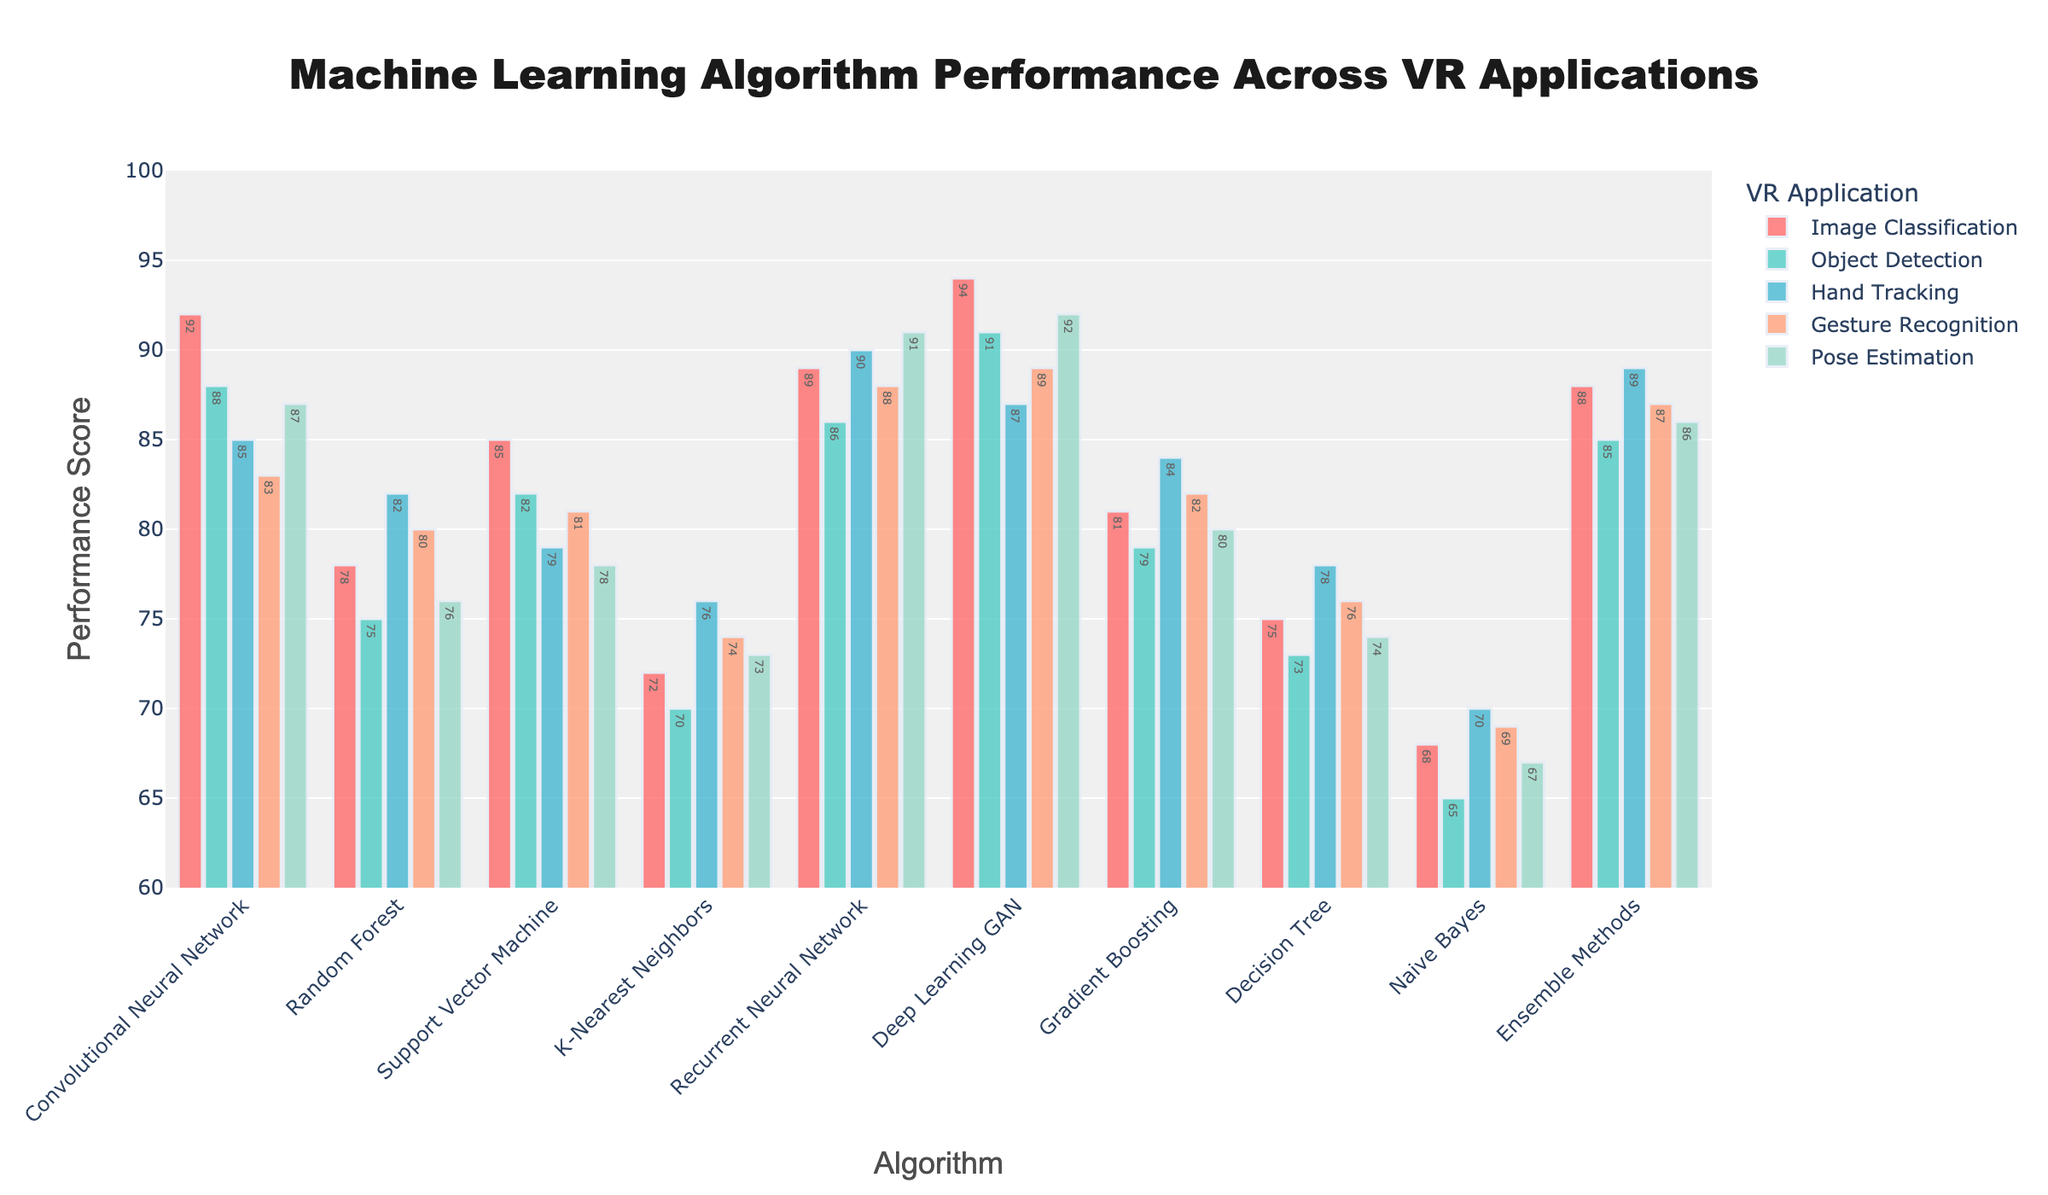What is the highest performance score achieved by any algorithm for Gesture Recognition? To find the highest performance score, look at the bar heights for Gesture Recognition across all algorithms. The highest bar is "Deep Learning GAN" with a score of 89.
Answer: 89 Which algorithm performs better in Hand Tracking, Convolutional Neural Network or Support Vector Machine? Compare the bar heights of Convolutional Neural Network (85) and Support Vector Machine (79) in Hand Tracking. The Convolutional Neural Network has the higher score.
Answer: Convolutional Neural Network How many algorithms scored above 80 in Image Classification? Count all algorithms with bars above the 80 mark in the Image Classification category. The algorithms are: Convolutional Neural Network, Support Vector Machine, Recurrent Neural Network, Deep Learning GAN, and Ensemble Methods. There are 5 algorithms.
Answer: 5 Which VR application does Gradient Boosting perform the worst in? Look at the bars for Gradient Boosting across all VR applications. The lowest bar corresponds to Object Detection with a performance score of 79.
Answer: Object Detection What is the average performance score of the Recurrent Neural Network across all VR applications? Add up the scores for Recurrent Neural Network in all applications and divide by the number of applications: (89 + 86 + 90 + 88 + 91) / 5 = 88.8
Answer: 88.8 Between Decision Tree and Naive Bayes, which algorithm has a higher visual bar in Pose Estimation? Compare the bar heights for Decision Tree (74) and Naive Bayes (67) in Pose Estimation. Decision Tree has a higher bar.
Answer: Decision Tree What is the sum of performance scores for Ensemble Methods in Image Classification and Gesture Recognition? Add the performance scores for Ensemble Methods in Image Classification (88) and Gesture Recognition (87): 88 + 87 = 175
Answer: 175 Which application shows the most variation in performance scores among all algorithms? Look at the range of bar heights for each application. Image Classification ranges from 68 (Naive Bayes) to 94 (Deep Learning GAN), showing a variation of 26 points, which is the highest compared to other applications.
Answer: Image Classification 